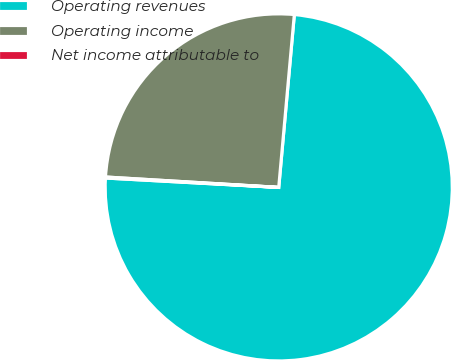Convert chart. <chart><loc_0><loc_0><loc_500><loc_500><pie_chart><fcel>Operating revenues<fcel>Operating income<fcel>Net income attributable to<nl><fcel>74.43%<fcel>25.48%<fcel>0.09%<nl></chart> 